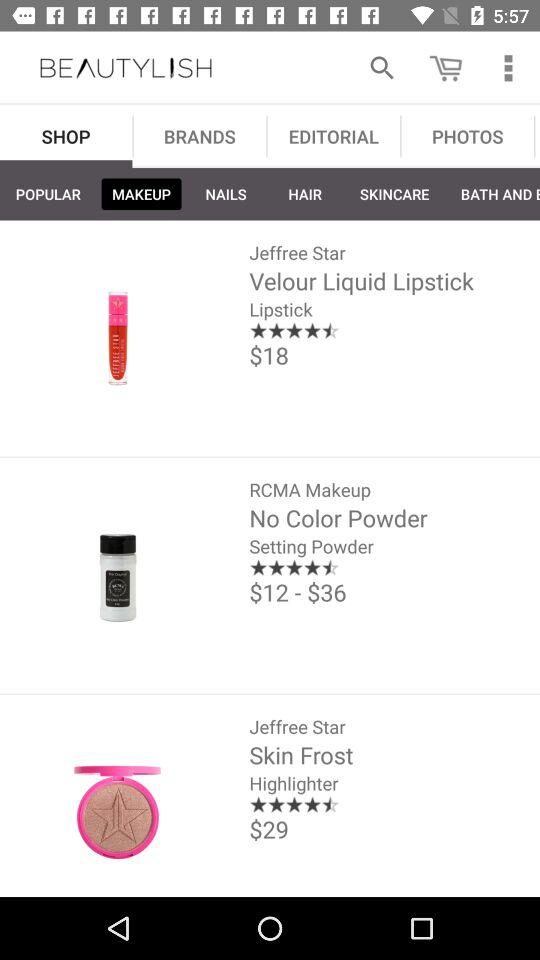Which tab has been selected? The selected tabs are "SHOP" and "MAKEUP". 